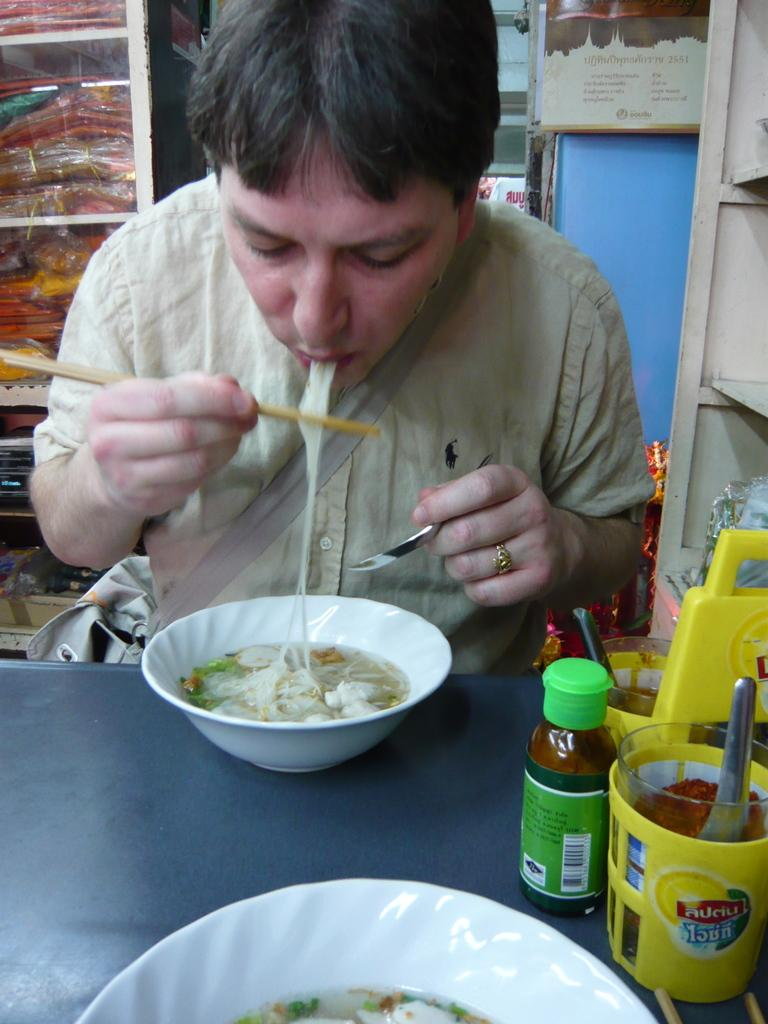Provide a one-sentence caption for the provided image. A man eating soup with condiments on a table including one called Auciu. 